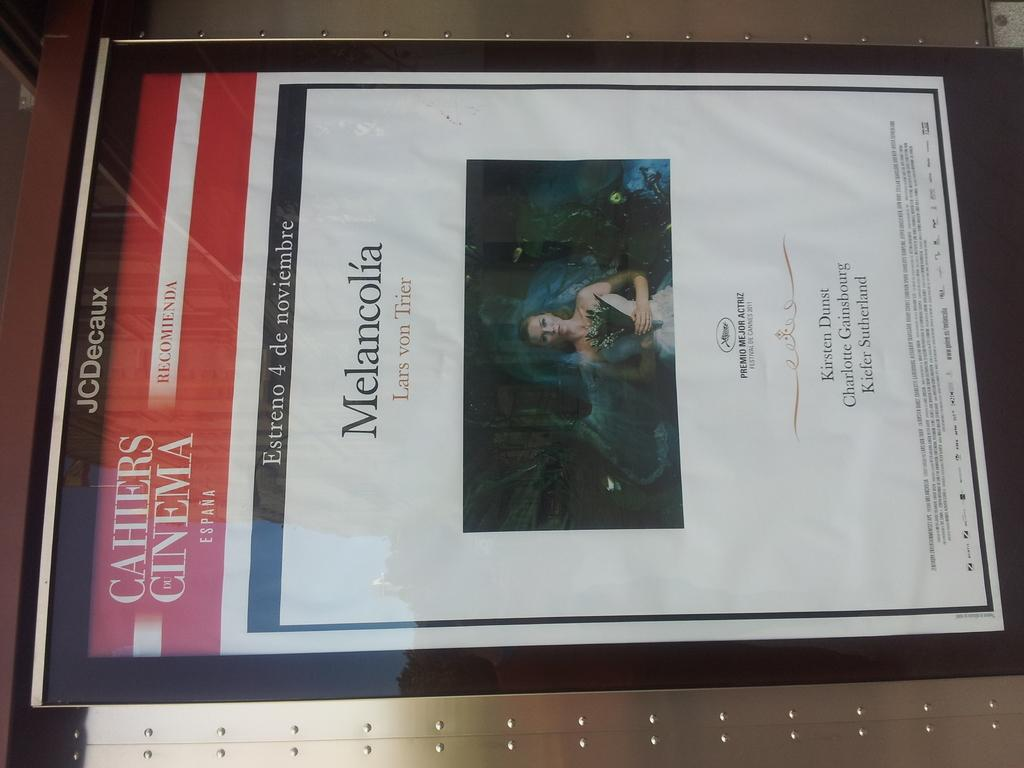<image>
Share a concise interpretation of the image provided. Behind a table loaded with books a man wears a shirt that says Miraflores Lee. 